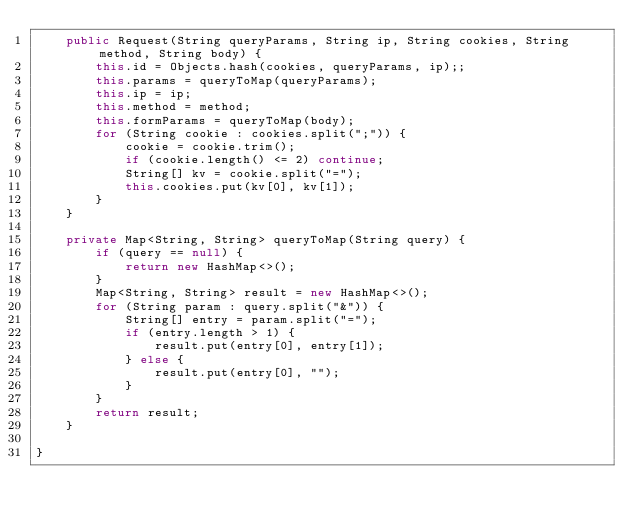<code> <loc_0><loc_0><loc_500><loc_500><_Java_>    public Request(String queryParams, String ip, String cookies, String method, String body) {
        this.id = Objects.hash(cookies, queryParams, ip);;
        this.params = queryToMap(queryParams);
        this.ip = ip;
        this.method = method;
        this.formParams = queryToMap(body);
        for (String cookie : cookies.split(";")) {
            cookie = cookie.trim();
            if (cookie.length() <= 2) continue;
            String[] kv = cookie.split("=");
            this.cookies.put(kv[0], kv[1]);
        }
    }

    private Map<String, String> queryToMap(String query) {
        if (query == null) {
            return new HashMap<>();
        }
        Map<String, String> result = new HashMap<>();
        for (String param : query.split("&")) {
            String[] entry = param.split("=");
            if (entry.length > 1) {
                result.put(entry[0], entry[1]);
            } else {
                result.put(entry[0], "");
            }
        }
        return result;
    }

}
</code> 